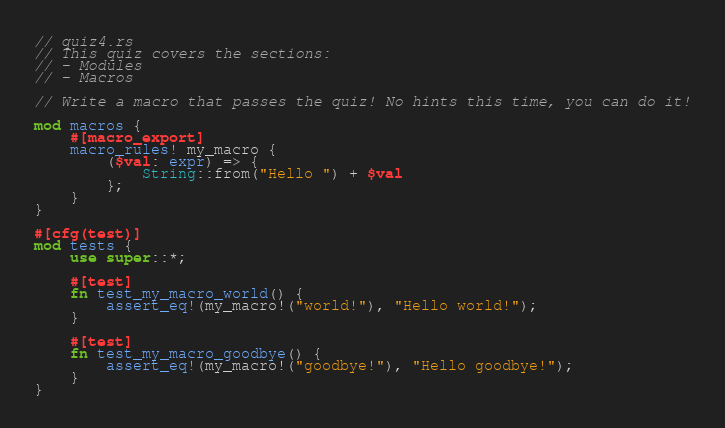<code> <loc_0><loc_0><loc_500><loc_500><_Rust_>// quiz4.rs
// This quiz covers the sections:
// - Modules
// - Macros

// Write a macro that passes the quiz! No hints this time, you can do it!

mod macros {
    #[macro_export]
    macro_rules! my_macro {
        ($val: expr) => {
            String::from("Hello ") + $val
        };
    }
}

#[cfg(test)]
mod tests {
    use super::*;

    #[test]
    fn test_my_macro_world() {
        assert_eq!(my_macro!("world!"), "Hello world!");
    }

    #[test]
    fn test_my_macro_goodbye() {
        assert_eq!(my_macro!("goodbye!"), "Hello goodbye!");
    }
}
</code> 